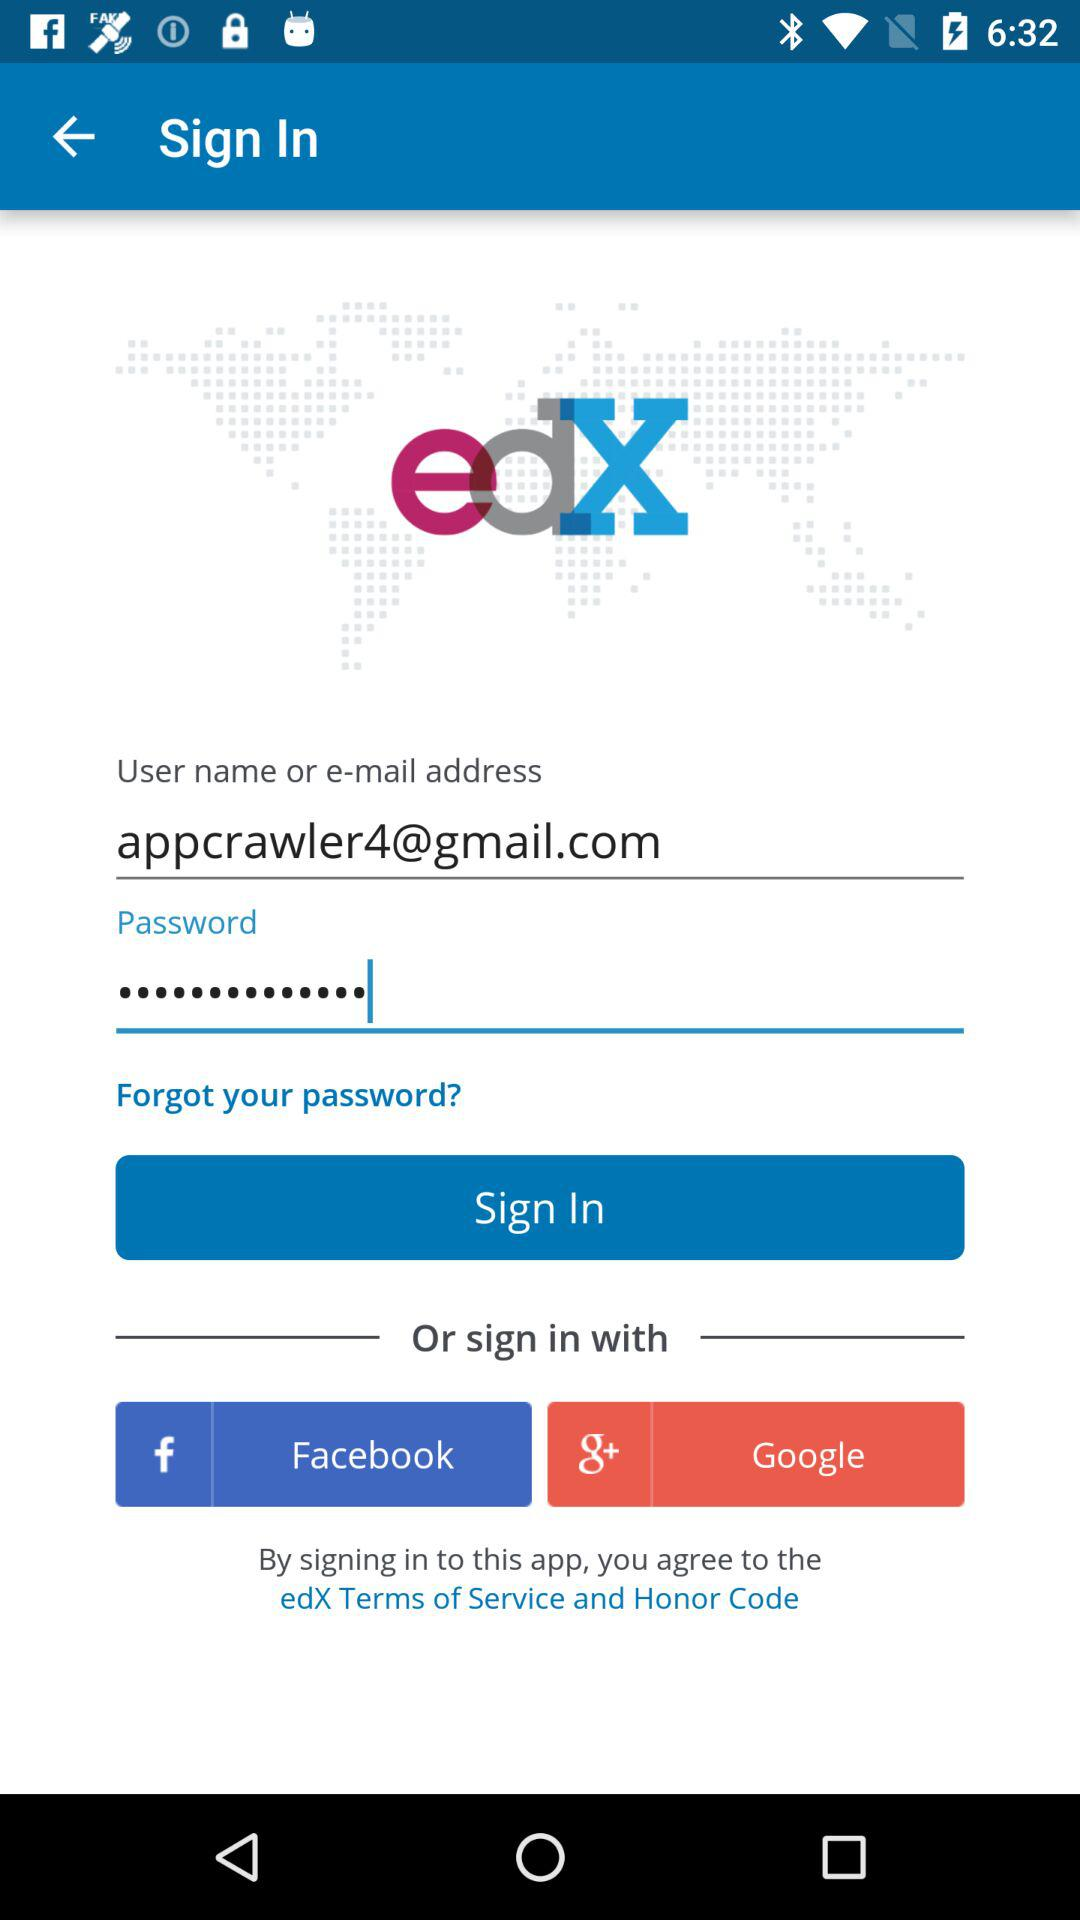What is the email address? The email address is appcrawler4@gmail.com. 